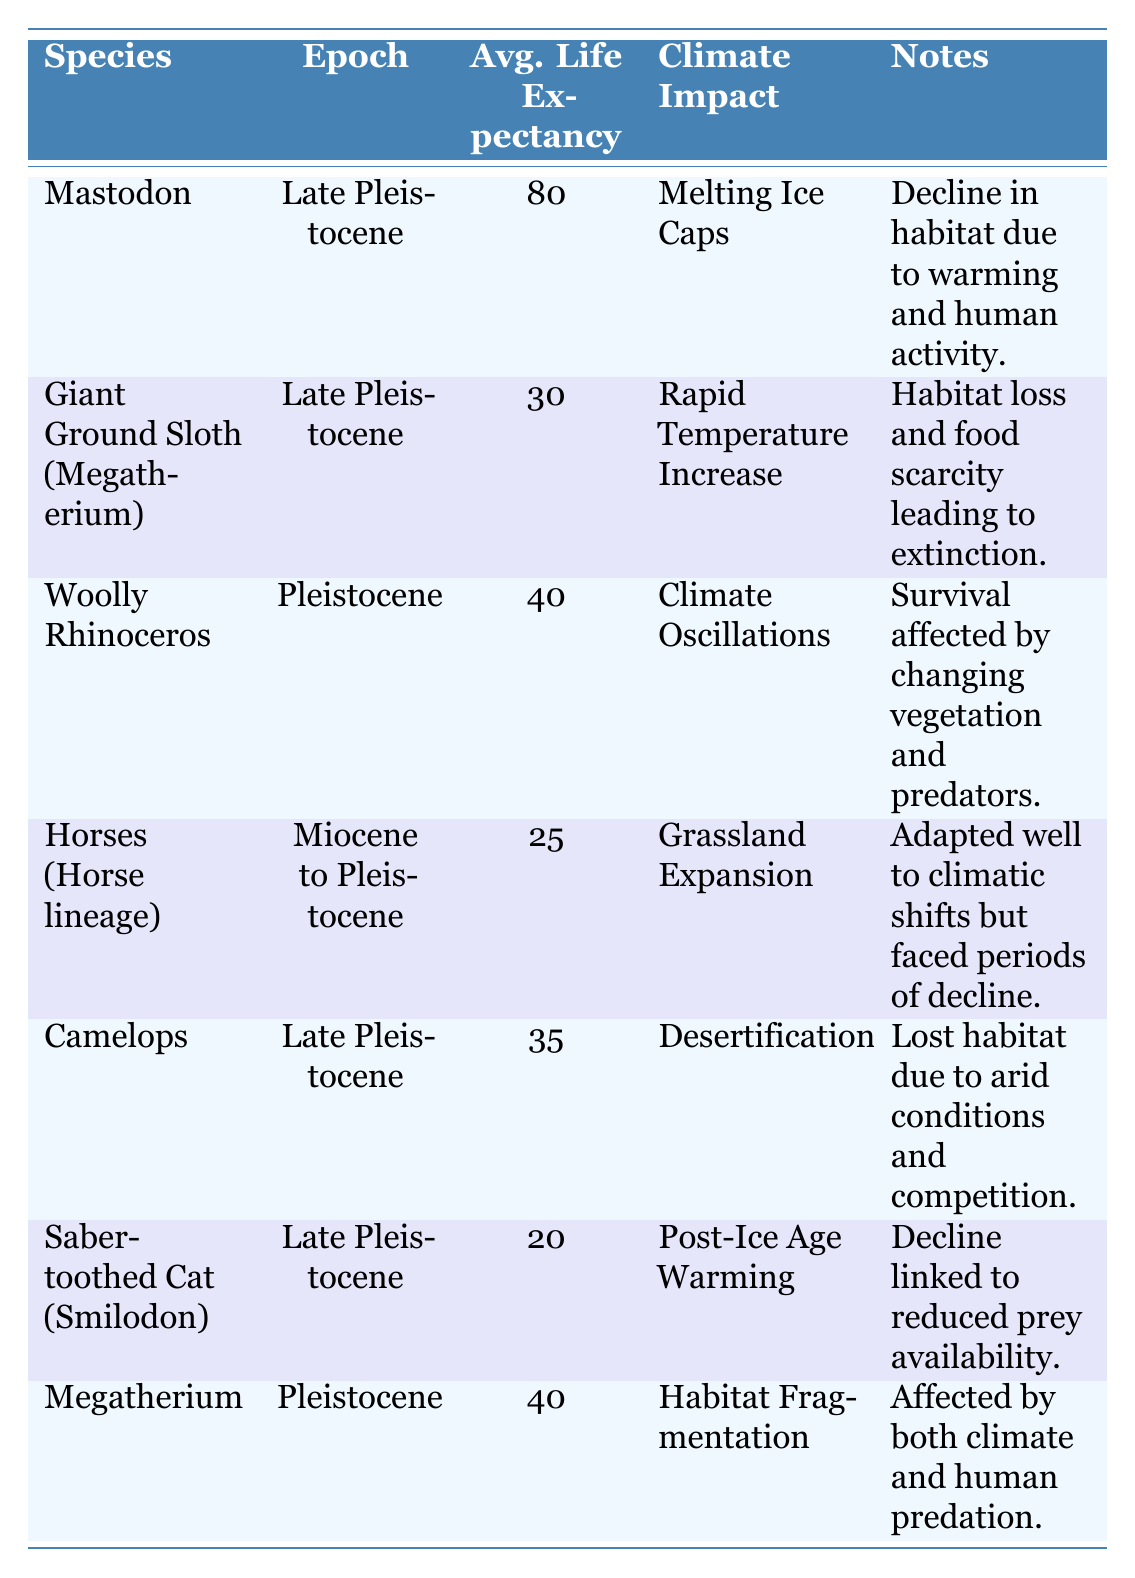What is the average life expectancy of the Saber-toothed Cat? The average life expectancy of the Saber-toothed Cat is 20 based on the table.
Answer: 20 In which epoch did the Woolly Rhinoceros live? The Woolly Rhinoceros lived during the Pleistocene, as listed in the table.
Answer: Pleistocene Which species had the longest average life expectancy? The Mastodon had the longest average life expectancy of 80, which can be identified by comparing the values in the Average Life Expectancy column.
Answer: 80 What is the difference in average life expectancy between the Mastodon and the Giant Ground Sloth? The difference can be calculated as follows: Mastodon (80) - Giant Ground Sloth (30) = 50. Thus, the difference is 50 years.
Answer: 50 Did climate change have any impact on the life expectancy of the Megatherium? Yes, the table indicates that habitat fragmentation due to climate, along with human predation, affected the Megatherium.
Answer: Yes How many species mentioned had an average life expectancy of less than 30 years? The Saber-toothed Cat and Horses had an average life expectancy of less than 30 years. Therefore, there are two species.
Answer: 2 What average life expectancy does the species Camelops have and what climate impact contributed to it? The Camelops had an average life expectancy of 35, and its decline was due to desertification, according to the table.
Answer: 35, Desertification Which species experienced habitat loss due to 'Rapid Temperature Increase'? The Giant Ground Sloth (Megatherium) is listed as experiencing habitat loss due to Rapid Temperature Increase in the climate impact column.
Answer: Giant Ground Sloth (Megatherium) Which species had an average life expectancy of more than 30 years but less than 50 years? The Woolly Rhinoceros and Megatherium had an average life expectancy of 40 each, fitting the criteria of being more than 30 but less than 50.
Answer: Woolly Rhinoceros, Megatherium 